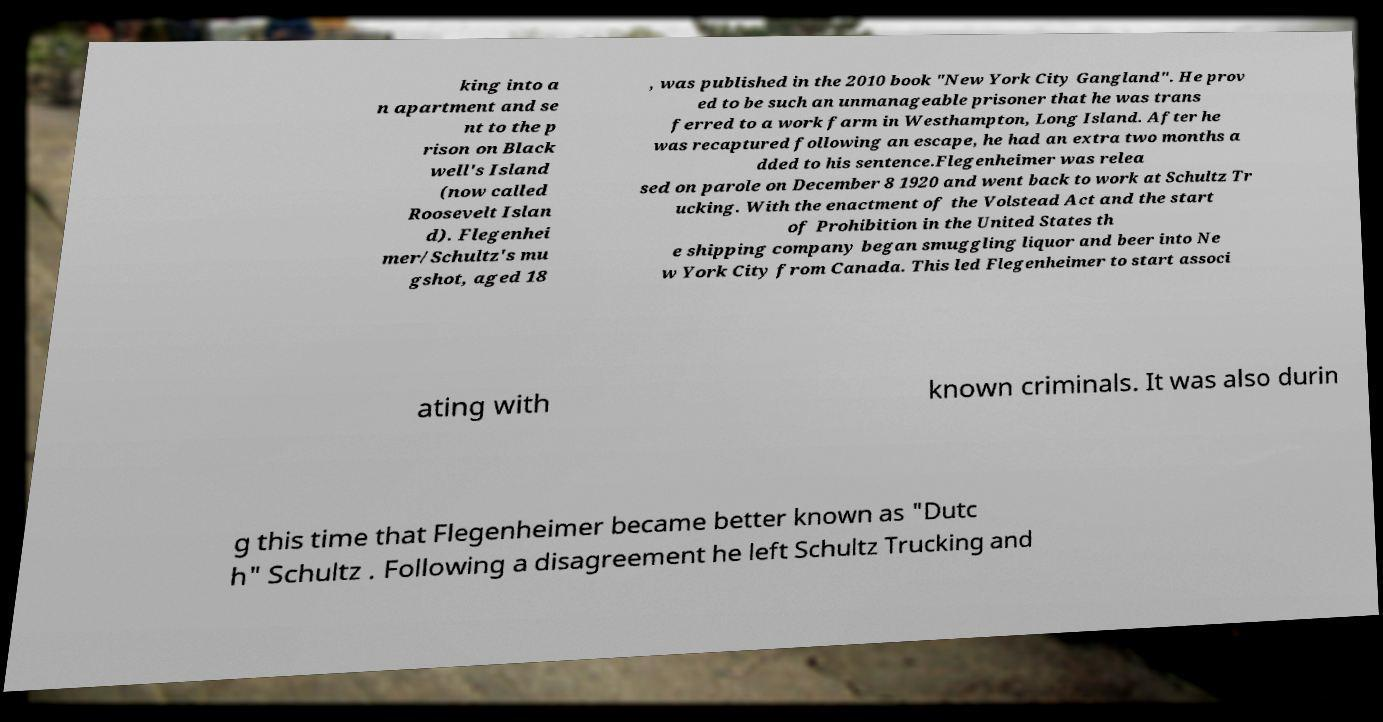I need the written content from this picture converted into text. Can you do that? king into a n apartment and se nt to the p rison on Black well's Island (now called Roosevelt Islan d). Flegenhei mer/Schultz's mu gshot, aged 18 , was published in the 2010 book "New York City Gangland". He prov ed to be such an unmanageable prisoner that he was trans ferred to a work farm in Westhampton, Long Island. After he was recaptured following an escape, he had an extra two months a dded to his sentence.Flegenheimer was relea sed on parole on December 8 1920 and went back to work at Schultz Tr ucking. With the enactment of the Volstead Act and the start of Prohibition in the United States th e shipping company began smuggling liquor and beer into Ne w York City from Canada. This led Flegenheimer to start associ ating with known criminals. It was also durin g this time that Flegenheimer became better known as "Dutc h" Schultz . Following a disagreement he left Schultz Trucking and 